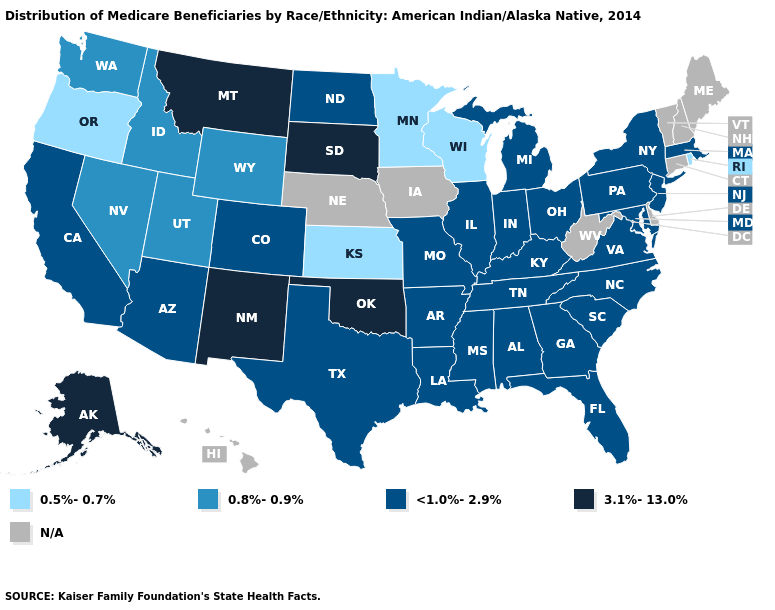Which states hav the highest value in the Northeast?
Answer briefly. Massachusetts, New Jersey, New York, Pennsylvania. What is the value of Georgia?
Quick response, please. <1.0%-2.9%. Name the states that have a value in the range 0.5%-0.7%?
Concise answer only. Kansas, Minnesota, Oregon, Rhode Island, Wisconsin. What is the value of Oklahoma?
Concise answer only. 3.1%-13.0%. What is the highest value in the USA?
Short answer required. 3.1%-13.0%. Is the legend a continuous bar?
Answer briefly. No. Which states have the lowest value in the USA?
Quick response, please. Kansas, Minnesota, Oregon, Rhode Island, Wisconsin. Does North Dakota have the highest value in the USA?
Keep it brief. No. Does South Carolina have the highest value in the USA?
Quick response, please. No. What is the highest value in states that border Kentucky?
Keep it brief. <1.0%-2.9%. What is the value of Iowa?
Short answer required. N/A. Name the states that have a value in the range <1.0%-2.9%?
Give a very brief answer. Alabama, Arizona, Arkansas, California, Colorado, Florida, Georgia, Illinois, Indiana, Kentucky, Louisiana, Maryland, Massachusetts, Michigan, Mississippi, Missouri, New Jersey, New York, North Carolina, North Dakota, Ohio, Pennsylvania, South Carolina, Tennessee, Texas, Virginia. What is the lowest value in states that border Wisconsin?
Keep it brief. 0.5%-0.7%. What is the value of North Carolina?
Write a very short answer. <1.0%-2.9%. 